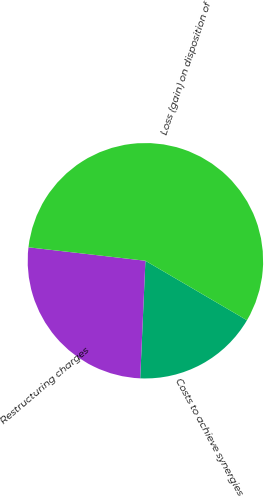Convert chart. <chart><loc_0><loc_0><loc_500><loc_500><pie_chart><fcel>Costs to achieve synergies<fcel>Restructuring charges<fcel>Loss (gain) on disposition of<nl><fcel>17.27%<fcel>26.12%<fcel>56.61%<nl></chart> 